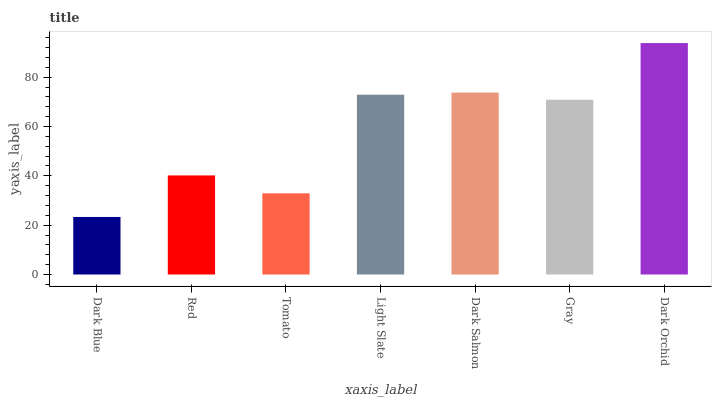Is Dark Blue the minimum?
Answer yes or no. Yes. Is Dark Orchid the maximum?
Answer yes or no. Yes. Is Red the minimum?
Answer yes or no. No. Is Red the maximum?
Answer yes or no. No. Is Red greater than Dark Blue?
Answer yes or no. Yes. Is Dark Blue less than Red?
Answer yes or no. Yes. Is Dark Blue greater than Red?
Answer yes or no. No. Is Red less than Dark Blue?
Answer yes or no. No. Is Gray the high median?
Answer yes or no. Yes. Is Gray the low median?
Answer yes or no. Yes. Is Tomato the high median?
Answer yes or no. No. Is Dark Blue the low median?
Answer yes or no. No. 